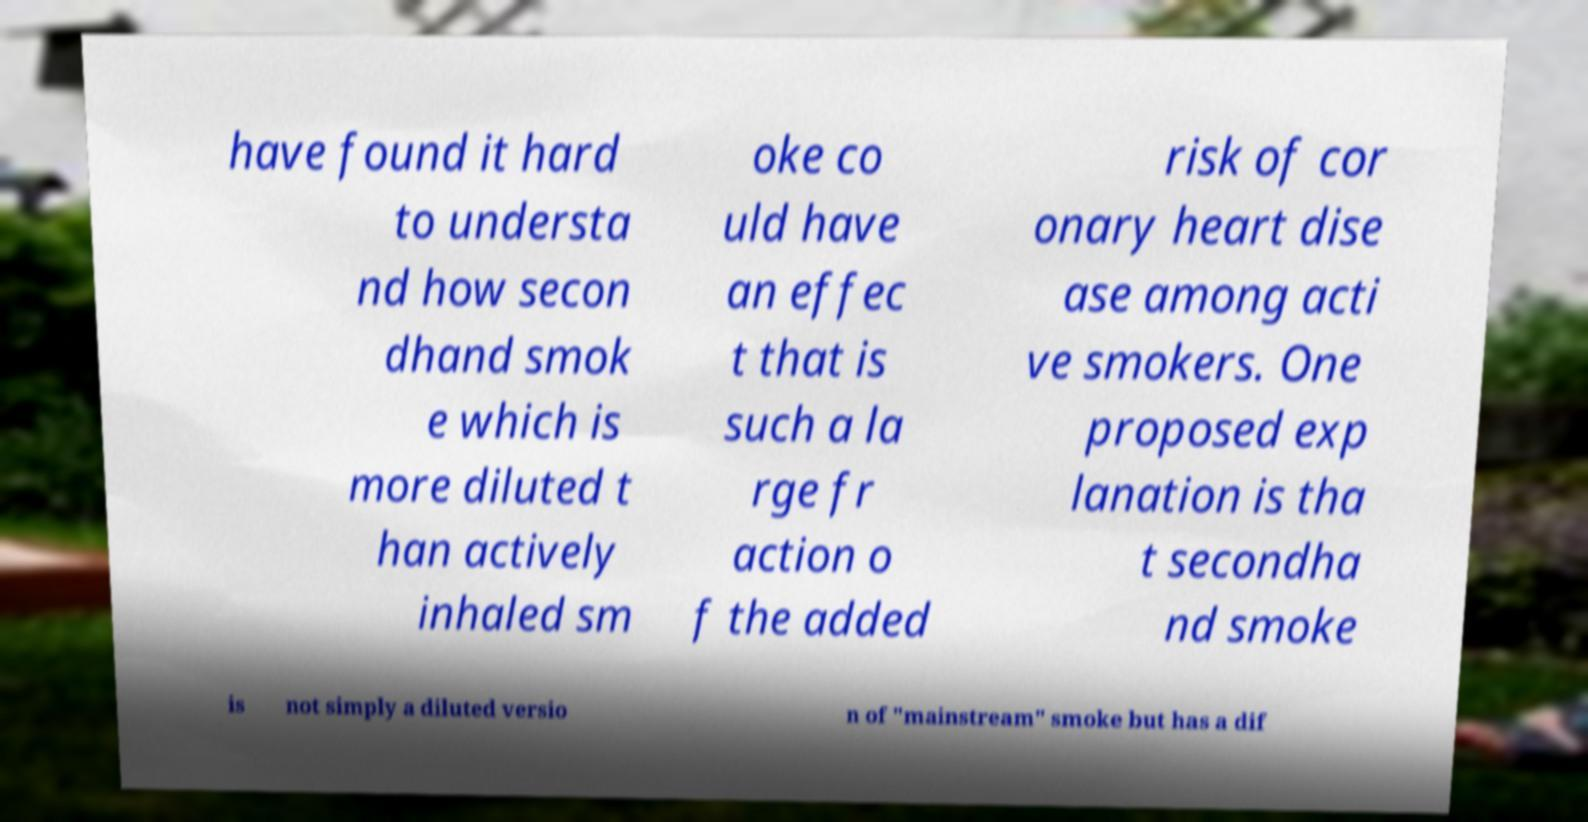Please identify and transcribe the text found in this image. have found it hard to understa nd how secon dhand smok e which is more diluted t han actively inhaled sm oke co uld have an effec t that is such a la rge fr action o f the added risk of cor onary heart dise ase among acti ve smokers. One proposed exp lanation is tha t secondha nd smoke is not simply a diluted versio n of "mainstream" smoke but has a dif 